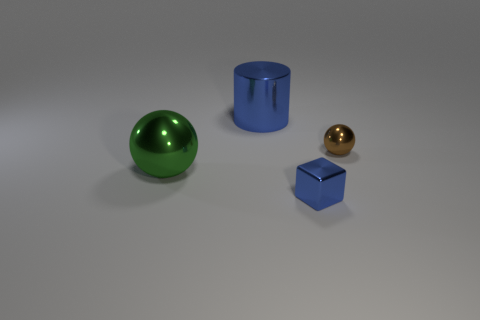What is the size of the thing that is the same color as the small shiny cube?
Keep it short and to the point. Large. What number of objects are blue shiny cubes or big blue rubber cylinders?
Provide a succinct answer. 1. There is a large green thing; what shape is it?
Keep it short and to the point. Sphere. The other shiny object that is the same shape as the tiny brown object is what size?
Provide a succinct answer. Large. There is a blue thing that is behind the large metal thing that is in front of the small brown metal object; what is its size?
Offer a terse response. Large. Are there an equal number of green things behind the blue cylinder and big brown rubber cylinders?
Provide a short and direct response. Yes. How many other objects are there of the same color as the cube?
Give a very brief answer. 1. Are there fewer big things that are on the right side of the big metallic sphere than blocks?
Provide a succinct answer. No. Is there another object of the same size as the brown metallic thing?
Your answer should be very brief. Yes. Is the color of the metal block the same as the thing behind the small shiny sphere?
Keep it short and to the point. Yes. 